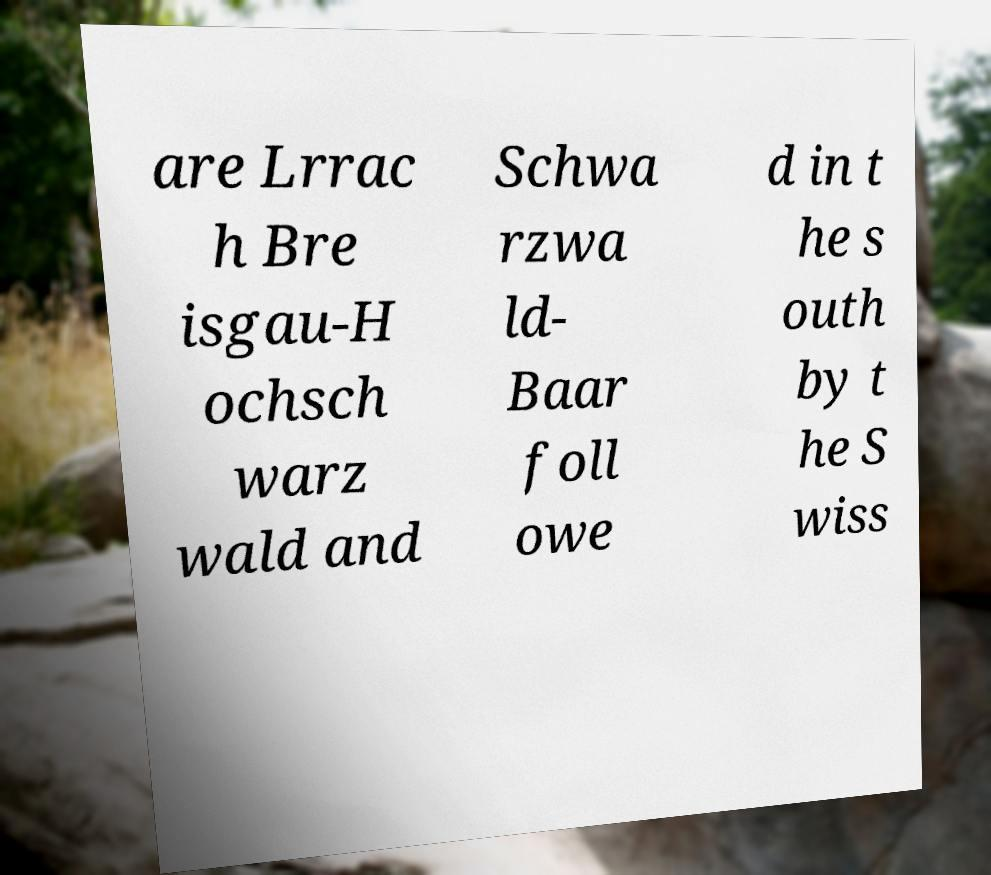Can you accurately transcribe the text from the provided image for me? are Lrrac h Bre isgau-H ochsch warz wald and Schwa rzwa ld- Baar foll owe d in t he s outh by t he S wiss 